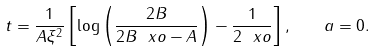Convert formula to latex. <formula><loc_0><loc_0><loc_500><loc_500>t = \frac { 1 } { A \xi ^ { 2 } } \left [ \log { \left ( \frac { 2 B } { 2 B \ x o - A } \right ) } - \frac { 1 } { 2 \ x o } \right ] , \quad a = 0 .</formula> 